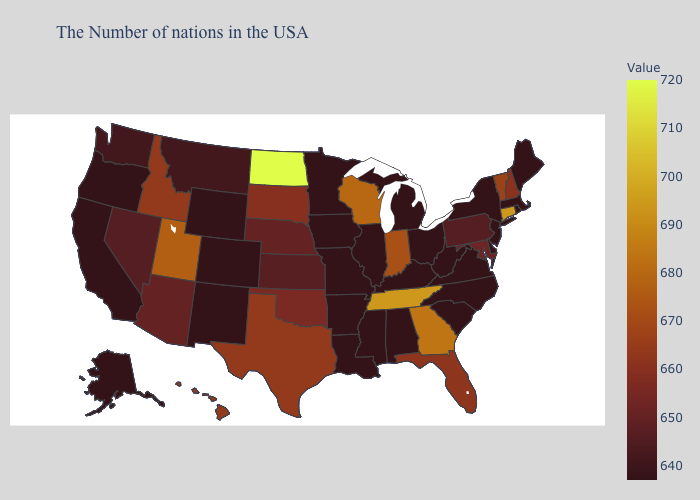Does Maine have the lowest value in the Northeast?
Short answer required. Yes. Among the states that border Illinois , which have the lowest value?
Keep it brief. Kentucky, Missouri, Iowa. Does the map have missing data?
Give a very brief answer. No. Among the states that border Alabama , which have the highest value?
Be succinct. Tennessee. Among the states that border Missouri , which have the lowest value?
Quick response, please. Kentucky, Illinois, Arkansas, Iowa. Does the map have missing data?
Short answer required. No. Does the map have missing data?
Be succinct. No. 